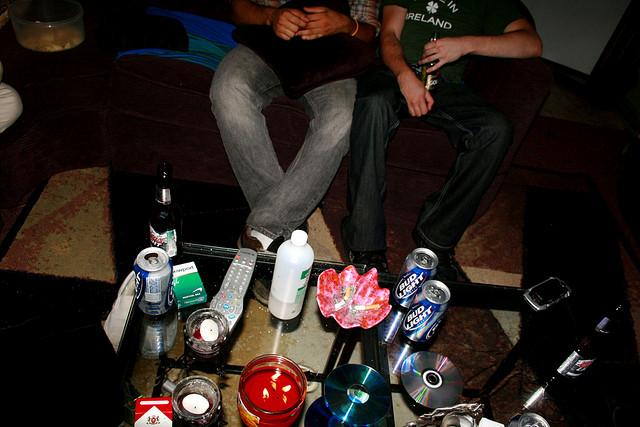Are these the lower appendages of comfortable people?
Concise answer only. Yes. What kind of beverage is in the cans?
Short answer required. Beer. What color is the Newport box?
Give a very brief answer. Green. 